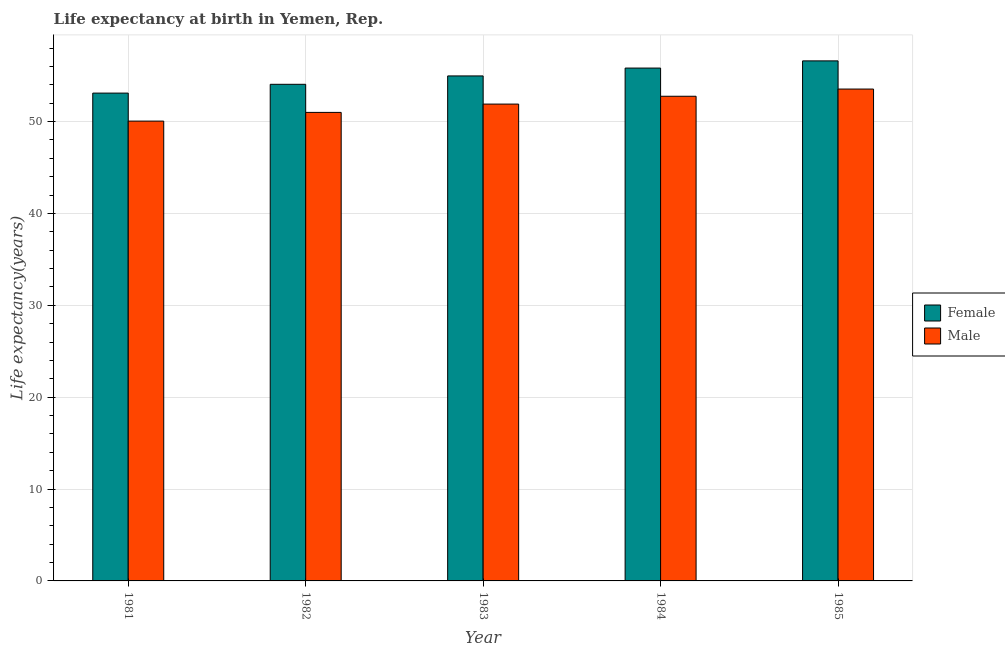Are the number of bars per tick equal to the number of legend labels?
Your answer should be compact. Yes. How many bars are there on the 4th tick from the right?
Provide a succinct answer. 2. In how many cases, is the number of bars for a given year not equal to the number of legend labels?
Offer a terse response. 0. What is the life expectancy(male) in 1985?
Keep it short and to the point. 53.54. Across all years, what is the maximum life expectancy(female)?
Offer a terse response. 56.61. Across all years, what is the minimum life expectancy(male)?
Offer a very short reply. 50.05. In which year was the life expectancy(female) maximum?
Your answer should be very brief. 1985. What is the total life expectancy(female) in the graph?
Offer a terse response. 274.57. What is the difference between the life expectancy(female) in 1982 and that in 1984?
Offer a terse response. -1.77. What is the difference between the life expectancy(female) in 1985 and the life expectancy(male) in 1984?
Offer a very short reply. 0.78. What is the average life expectancy(female) per year?
Offer a terse response. 54.91. What is the ratio of the life expectancy(male) in 1981 to that in 1985?
Your answer should be compact. 0.93. What is the difference between the highest and the second highest life expectancy(female)?
Provide a succinct answer. 0.78. What is the difference between the highest and the lowest life expectancy(male)?
Offer a very short reply. 3.49. In how many years, is the life expectancy(male) greater than the average life expectancy(male) taken over all years?
Provide a short and direct response. 3. Is the sum of the life expectancy(male) in 1981 and 1983 greater than the maximum life expectancy(female) across all years?
Give a very brief answer. Yes. How many bars are there?
Make the answer very short. 10. What is the difference between two consecutive major ticks on the Y-axis?
Give a very brief answer. 10. Are the values on the major ticks of Y-axis written in scientific E-notation?
Ensure brevity in your answer.  No. Does the graph contain any zero values?
Make the answer very short. No. Where does the legend appear in the graph?
Make the answer very short. Center right. What is the title of the graph?
Give a very brief answer. Life expectancy at birth in Yemen, Rep. What is the label or title of the Y-axis?
Provide a short and direct response. Life expectancy(years). What is the Life expectancy(years) of Female in 1981?
Ensure brevity in your answer.  53.1. What is the Life expectancy(years) in Male in 1981?
Your response must be concise. 50.05. What is the Life expectancy(years) in Female in 1982?
Provide a succinct answer. 54.06. What is the Life expectancy(years) of Male in 1982?
Offer a very short reply. 51. What is the Life expectancy(years) of Female in 1983?
Your answer should be compact. 54.97. What is the Life expectancy(years) in Male in 1983?
Offer a very short reply. 51.91. What is the Life expectancy(years) in Female in 1984?
Your response must be concise. 55.83. What is the Life expectancy(years) in Male in 1984?
Provide a succinct answer. 52.76. What is the Life expectancy(years) of Female in 1985?
Your answer should be very brief. 56.61. What is the Life expectancy(years) of Male in 1985?
Provide a short and direct response. 53.54. Across all years, what is the maximum Life expectancy(years) in Female?
Keep it short and to the point. 56.61. Across all years, what is the maximum Life expectancy(years) in Male?
Ensure brevity in your answer.  53.54. Across all years, what is the minimum Life expectancy(years) of Female?
Provide a succinct answer. 53.1. Across all years, what is the minimum Life expectancy(years) of Male?
Provide a succinct answer. 50.05. What is the total Life expectancy(years) of Female in the graph?
Provide a succinct answer. 274.57. What is the total Life expectancy(years) in Male in the graph?
Make the answer very short. 259.26. What is the difference between the Life expectancy(years) of Female in 1981 and that in 1982?
Your answer should be very brief. -0.96. What is the difference between the Life expectancy(years) in Male in 1981 and that in 1982?
Provide a succinct answer. -0.95. What is the difference between the Life expectancy(years) in Female in 1981 and that in 1983?
Provide a short and direct response. -1.87. What is the difference between the Life expectancy(years) of Male in 1981 and that in 1983?
Make the answer very short. -1.85. What is the difference between the Life expectancy(years) in Female in 1981 and that in 1984?
Offer a very short reply. -2.73. What is the difference between the Life expectancy(years) of Male in 1981 and that in 1984?
Offer a very short reply. -2.7. What is the difference between the Life expectancy(years) of Female in 1981 and that in 1985?
Offer a very short reply. -3.51. What is the difference between the Life expectancy(years) of Male in 1981 and that in 1985?
Provide a succinct answer. -3.49. What is the difference between the Life expectancy(years) in Female in 1982 and that in 1983?
Your answer should be very brief. -0.91. What is the difference between the Life expectancy(years) in Male in 1982 and that in 1983?
Provide a short and direct response. -0.91. What is the difference between the Life expectancy(years) in Female in 1982 and that in 1984?
Provide a short and direct response. -1.77. What is the difference between the Life expectancy(years) in Male in 1982 and that in 1984?
Make the answer very short. -1.76. What is the difference between the Life expectancy(years) of Female in 1982 and that in 1985?
Make the answer very short. -2.55. What is the difference between the Life expectancy(years) in Male in 1982 and that in 1985?
Your answer should be compact. -2.54. What is the difference between the Life expectancy(years) in Female in 1983 and that in 1984?
Give a very brief answer. -0.85. What is the difference between the Life expectancy(years) of Male in 1983 and that in 1984?
Keep it short and to the point. -0.85. What is the difference between the Life expectancy(years) in Female in 1983 and that in 1985?
Your response must be concise. -1.64. What is the difference between the Life expectancy(years) of Male in 1983 and that in 1985?
Provide a succinct answer. -1.64. What is the difference between the Life expectancy(years) of Female in 1984 and that in 1985?
Offer a terse response. -0.78. What is the difference between the Life expectancy(years) of Male in 1984 and that in 1985?
Provide a succinct answer. -0.78. What is the difference between the Life expectancy(years) of Female in 1981 and the Life expectancy(years) of Male in 1982?
Your response must be concise. 2.1. What is the difference between the Life expectancy(years) in Female in 1981 and the Life expectancy(years) in Male in 1983?
Your answer should be compact. 1.2. What is the difference between the Life expectancy(years) of Female in 1981 and the Life expectancy(years) of Male in 1984?
Offer a terse response. 0.34. What is the difference between the Life expectancy(years) in Female in 1981 and the Life expectancy(years) in Male in 1985?
Provide a succinct answer. -0.44. What is the difference between the Life expectancy(years) of Female in 1982 and the Life expectancy(years) of Male in 1983?
Provide a short and direct response. 2.15. What is the difference between the Life expectancy(years) in Female in 1982 and the Life expectancy(years) in Male in 1985?
Keep it short and to the point. 0.52. What is the difference between the Life expectancy(years) of Female in 1983 and the Life expectancy(years) of Male in 1984?
Provide a short and direct response. 2.21. What is the difference between the Life expectancy(years) of Female in 1983 and the Life expectancy(years) of Male in 1985?
Your answer should be very brief. 1.43. What is the difference between the Life expectancy(years) in Female in 1984 and the Life expectancy(years) in Male in 1985?
Offer a very short reply. 2.29. What is the average Life expectancy(years) in Female per year?
Your answer should be very brief. 54.91. What is the average Life expectancy(years) in Male per year?
Make the answer very short. 51.85. In the year 1981, what is the difference between the Life expectancy(years) of Female and Life expectancy(years) of Male?
Ensure brevity in your answer.  3.05. In the year 1982, what is the difference between the Life expectancy(years) of Female and Life expectancy(years) of Male?
Your answer should be very brief. 3.06. In the year 1983, what is the difference between the Life expectancy(years) in Female and Life expectancy(years) in Male?
Offer a very short reply. 3.06. In the year 1984, what is the difference between the Life expectancy(years) of Female and Life expectancy(years) of Male?
Your response must be concise. 3.07. In the year 1985, what is the difference between the Life expectancy(years) of Female and Life expectancy(years) of Male?
Offer a terse response. 3.07. What is the ratio of the Life expectancy(years) in Female in 1981 to that in 1982?
Provide a succinct answer. 0.98. What is the ratio of the Life expectancy(years) of Male in 1981 to that in 1982?
Ensure brevity in your answer.  0.98. What is the ratio of the Life expectancy(years) in Female in 1981 to that in 1983?
Give a very brief answer. 0.97. What is the ratio of the Life expectancy(years) in Male in 1981 to that in 1983?
Provide a short and direct response. 0.96. What is the ratio of the Life expectancy(years) in Female in 1981 to that in 1984?
Ensure brevity in your answer.  0.95. What is the ratio of the Life expectancy(years) in Male in 1981 to that in 1984?
Provide a short and direct response. 0.95. What is the ratio of the Life expectancy(years) of Female in 1981 to that in 1985?
Your answer should be compact. 0.94. What is the ratio of the Life expectancy(years) of Male in 1981 to that in 1985?
Make the answer very short. 0.93. What is the ratio of the Life expectancy(years) in Female in 1982 to that in 1983?
Your answer should be very brief. 0.98. What is the ratio of the Life expectancy(years) in Male in 1982 to that in 1983?
Your response must be concise. 0.98. What is the ratio of the Life expectancy(years) in Female in 1982 to that in 1984?
Offer a very short reply. 0.97. What is the ratio of the Life expectancy(years) of Male in 1982 to that in 1984?
Provide a short and direct response. 0.97. What is the ratio of the Life expectancy(years) of Female in 1982 to that in 1985?
Keep it short and to the point. 0.95. What is the ratio of the Life expectancy(years) of Male in 1982 to that in 1985?
Offer a terse response. 0.95. What is the ratio of the Life expectancy(years) in Female in 1983 to that in 1984?
Ensure brevity in your answer.  0.98. What is the ratio of the Life expectancy(years) of Male in 1983 to that in 1984?
Offer a very short reply. 0.98. What is the ratio of the Life expectancy(years) of Female in 1983 to that in 1985?
Make the answer very short. 0.97. What is the ratio of the Life expectancy(years) in Male in 1983 to that in 1985?
Provide a succinct answer. 0.97. What is the ratio of the Life expectancy(years) of Female in 1984 to that in 1985?
Your response must be concise. 0.99. What is the ratio of the Life expectancy(years) of Male in 1984 to that in 1985?
Make the answer very short. 0.99. What is the difference between the highest and the second highest Life expectancy(years) of Female?
Offer a terse response. 0.78. What is the difference between the highest and the second highest Life expectancy(years) in Male?
Keep it short and to the point. 0.78. What is the difference between the highest and the lowest Life expectancy(years) in Female?
Your response must be concise. 3.51. What is the difference between the highest and the lowest Life expectancy(years) of Male?
Your response must be concise. 3.49. 